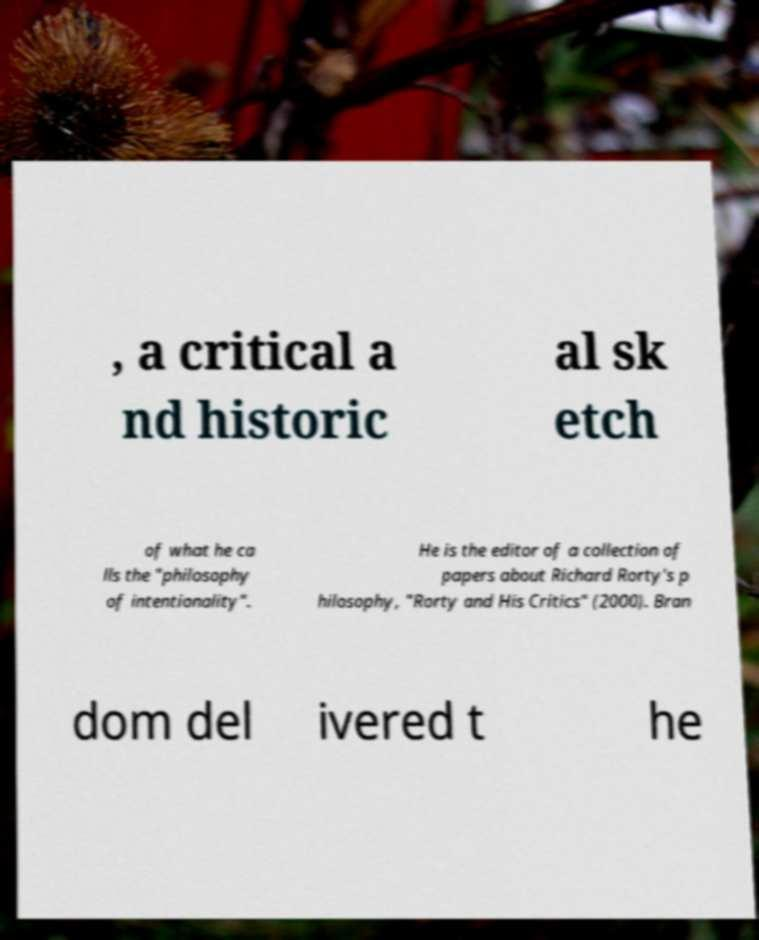Could you assist in decoding the text presented in this image and type it out clearly? , a critical a nd historic al sk etch of what he ca lls the "philosophy of intentionality". He is the editor of a collection of papers about Richard Rorty's p hilosophy, "Rorty and His Critics" (2000). Bran dom del ivered t he 